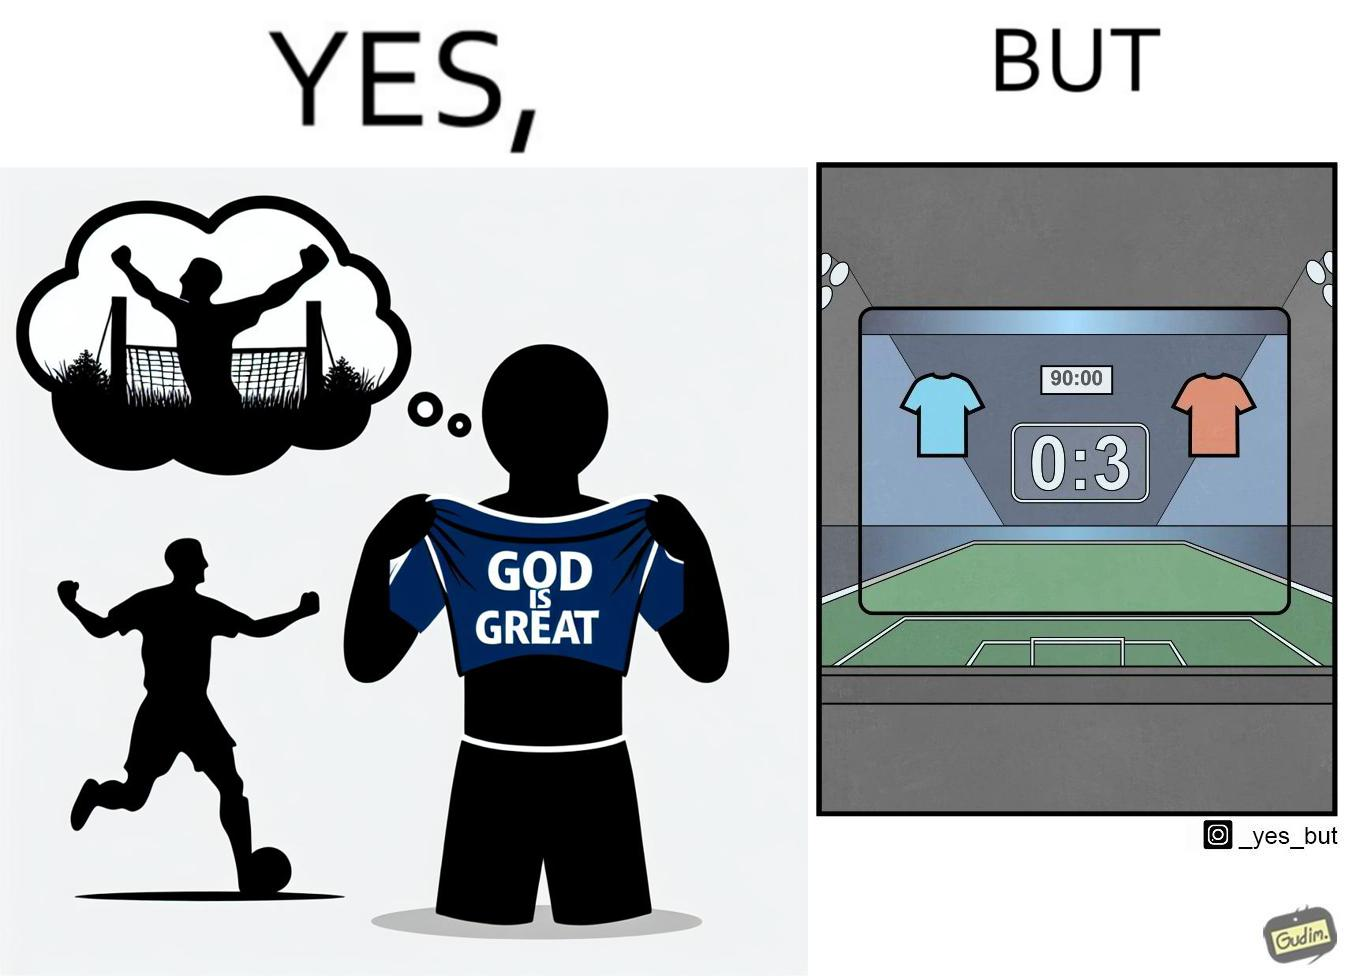What makes this image funny or satirical? The image is funny because the player thinks that when he scores a goal he will thank the god and show his t-shirt saying "GOD IS GREAT" but he ends up not being able to score any goals meaning that God did not want him to score any goals. 